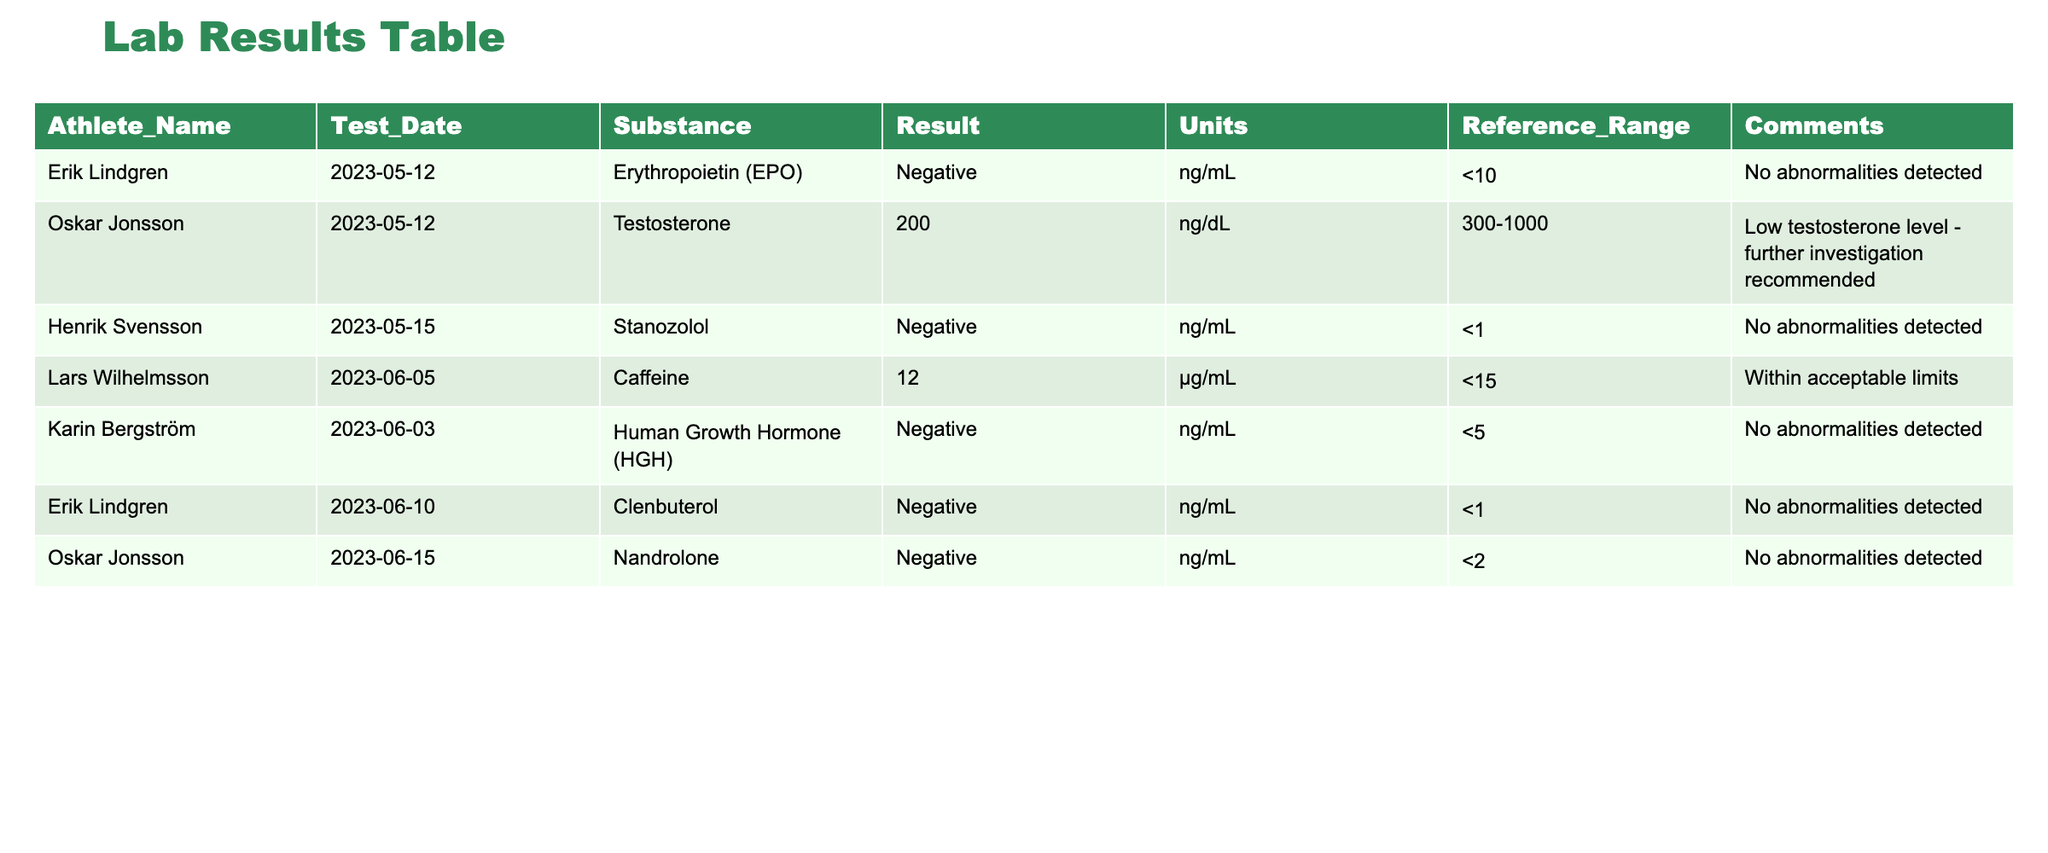What is the testosterone level of Oskar Jonsson? Oskar Jonsson has a testosterone level of 200 ng/dL based on the table row for this athlete.
Answer: 200 ng/dL Did Karin Bergström test positive for Human Growth Hormone (HGH)? The table shows that Karin Bergström's result for Human Growth Hormone (HGH) is Negative, indicating no positive test result for this substance.
Answer: No What is the reference range for testosterone levels according to the table? The reference range for testosterone levels, as listed in the table, is 300-1000 ng/dL.
Answer: 300-1000 ng/dL How many athletes tested negative for substances? From the table, Erik Lindgren, Henrik Svensson, Karin Bergström, and Oskar Jonsson tested negative. There are 5 athletes who tested negative, out of the total of 7 listed, with only Oskar Jonsson testing positive for low testosterone.
Answer: 5 What is the total amount of caffeine detected in Lars Wilhelmsson's test? Lars Wilhelmsson tested at 12 µg/mL for caffeine. This is the only amount listed, therefore, the total is simply 12 µg/mL.
Answer: 12 µg/mL What is the difference between the reference range for testosterone and Oskar Jonsson's level? The reference range for testosterone is 300-1000 ng/dL. Oskar Jonsson's level is 200 ng/dL which is below the lower limit of the reference range. The difference can be calculated by taking the lower limit 300 ng/dL and subtracting Oskar's level, resulting in a difference of 100 ng/dL.
Answer: 100 ng/dL Is there any athlete with a caffeine level above the reference range? The reference range for caffeine is <15 µg/mL and Lars Wilhelmsson has a caffeine level of 12 µg/mL which is within this limit. Therefore, no athlete has exceeded the reference range for caffeine.
Answer: No Who is the athlete with the highest detected substance result? The only substance with a result listed is Oskar Jonsson's testosterone level at 200 ng/dL, which is the highest substance result compared to others that came back negative. The reference limits indicate this result as low.
Answer: Oskar Jonsson 